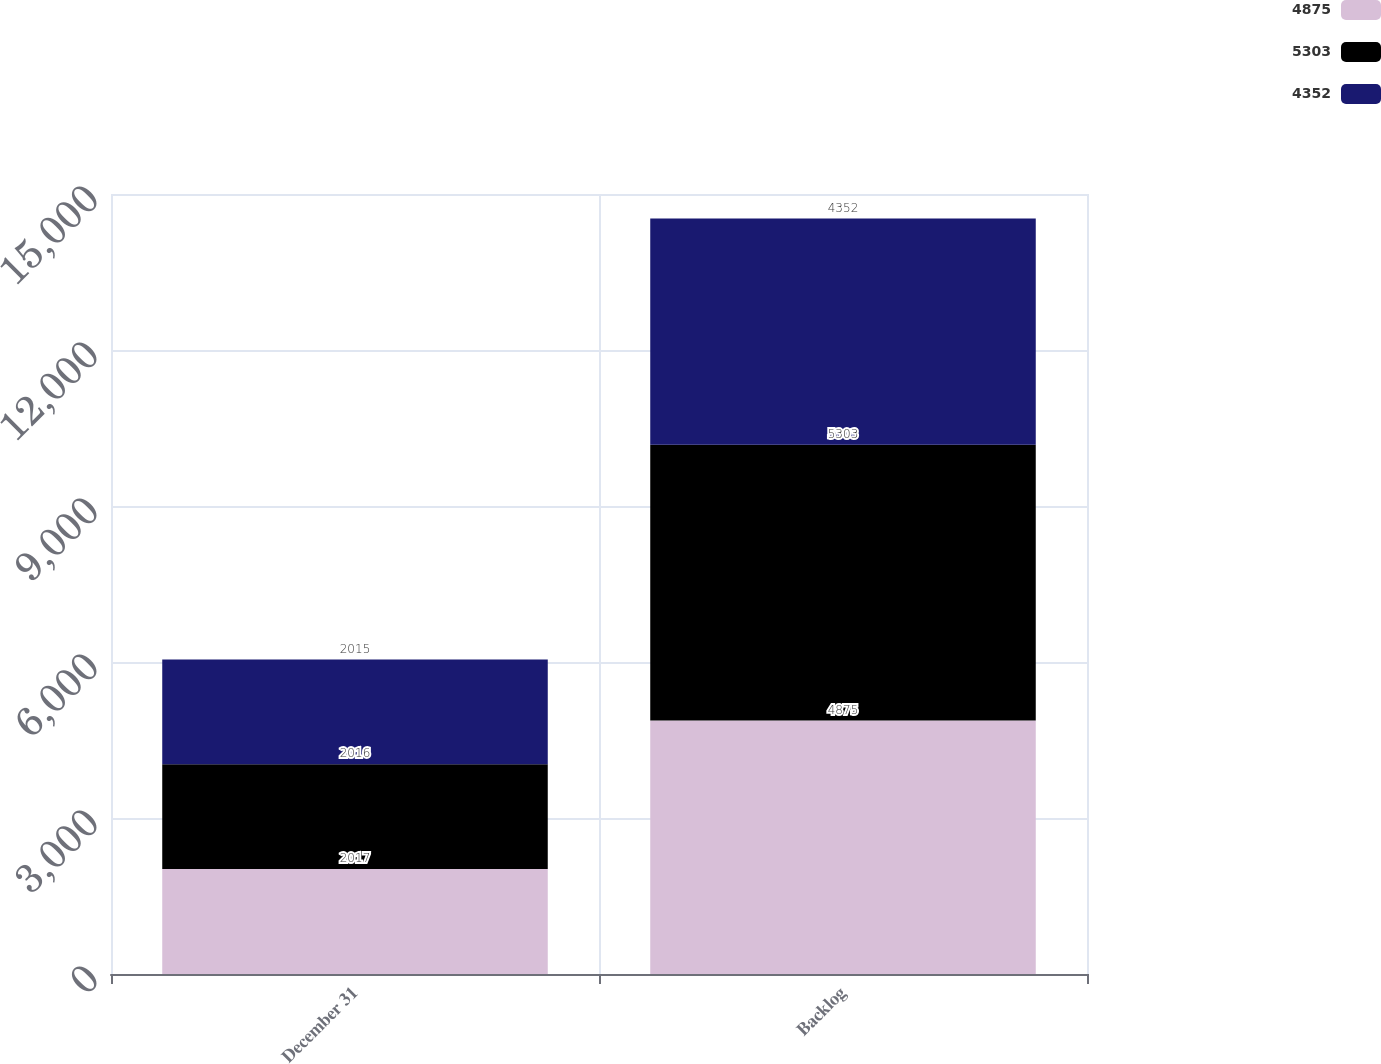Convert chart. <chart><loc_0><loc_0><loc_500><loc_500><stacked_bar_chart><ecel><fcel>December 31<fcel>Backlog<nl><fcel>4875<fcel>2017<fcel>4875<nl><fcel>5303<fcel>2016<fcel>5303<nl><fcel>4352<fcel>2015<fcel>4352<nl></chart> 